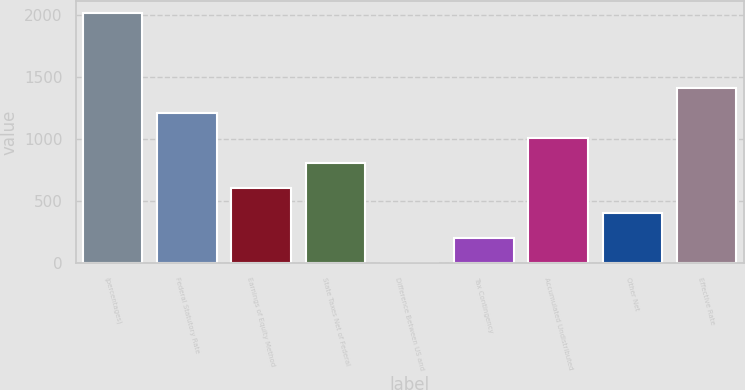<chart> <loc_0><loc_0><loc_500><loc_500><bar_chart><fcel>(percentages)<fcel>Federal Statutory Rate<fcel>Earnings of Equity Method<fcel>State Taxes Net of Federal<fcel>Difference Between US and<fcel>Tax Contingency<fcel>Accumulated Undistributed<fcel>Other Net<fcel>Effective Rate<nl><fcel>2016<fcel>1209.64<fcel>604.87<fcel>806.46<fcel>0.1<fcel>201.69<fcel>1008.05<fcel>403.28<fcel>1411.23<nl></chart> 